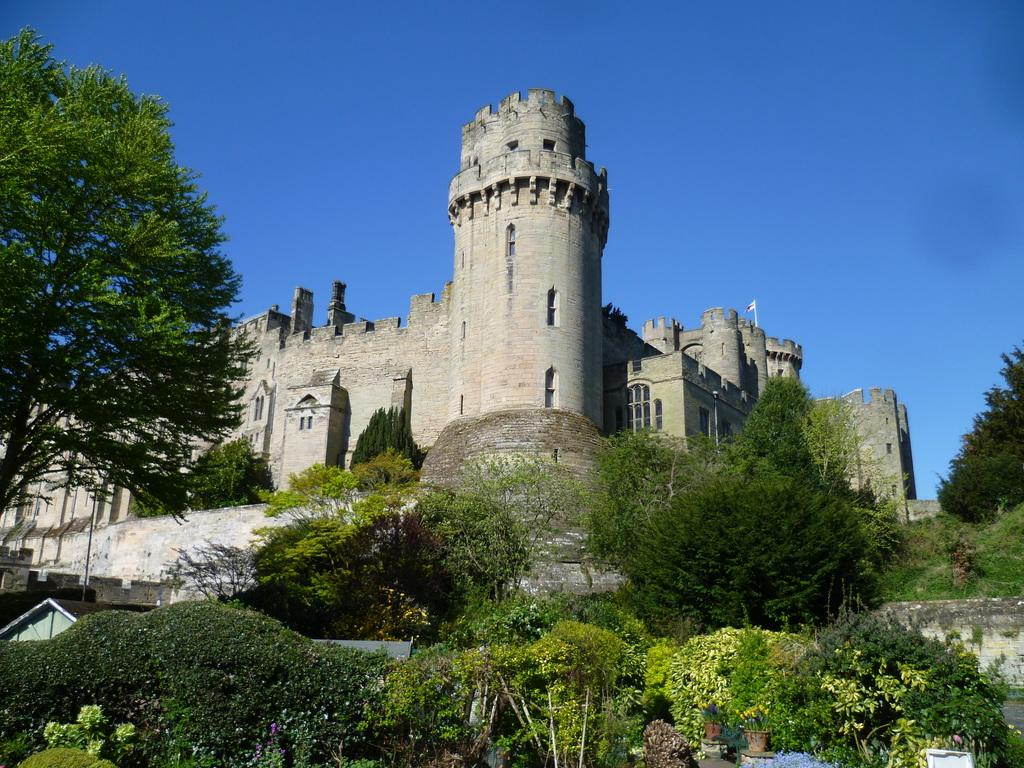What type of structure is in the image? There is a fort in the image. What can be seen in the background of the image? There are many trees and plants in the image. Where is the house located in the image? The house is at the left side of the image. What is visible at the top of the image? The sky is visible in the image. What color is the grape that the kitten is holding in the image? There is no grape or kitten present in the image. 